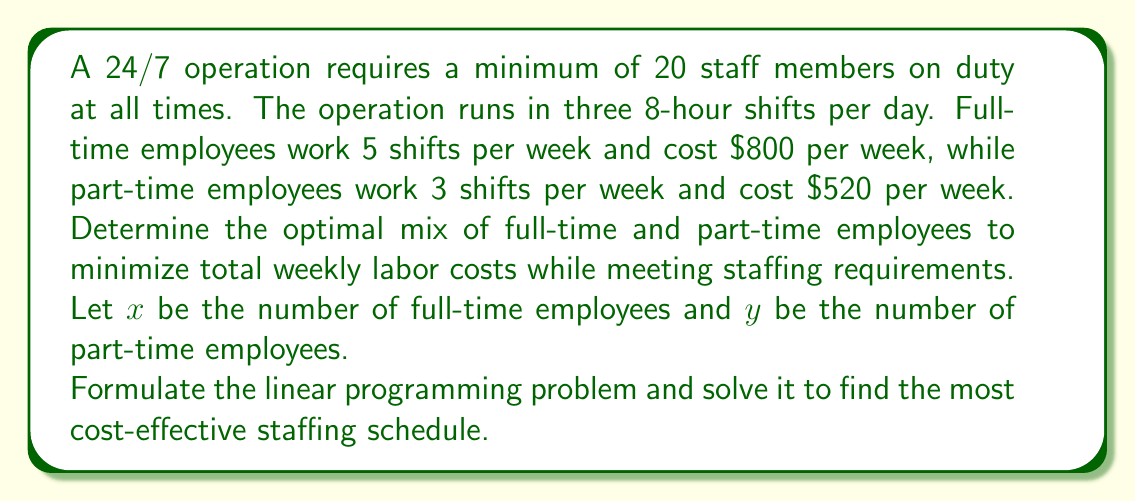Teach me how to tackle this problem. To solve this optimization problem, we need to formulate it as a linear programming problem and then solve it.

1. Objective function:
   Minimize total weekly cost: $C = 800x + 520y$

2. Constraints:
   a) Staffing requirement for each day:
      Full-time employees work 5 shifts per week, so on average 5/7 shifts per day.
      Part-time employees work 3 shifts per week, so on average 3/7 shifts per day.
      For each day: $\frac{5}{7}x + \frac{3}{7}y \geq 60$ (20 staff × 3 shifts)

   b) Non-negativity constraints:
      $x \geq 0$ and $y \geq 0$

3. Simplify the constraint:
   Multiply both sides by 7: $5x + 3y \geq 420$

4. Solve graphically or using the simplex method:
   The feasible region is bounded by the lines:
   $5x + 3y = 420$
   $x = 0$
   $y = 0$

   The optimal solution will be at one of the corner points of this region.

5. Corner points:
   a) (84, 0): C = 800(84) + 520(0) = 67,200
   b) (0, 140): C = 800(0) + 520(140) = 72,800
   c) Intersection of $5x + 3y = 420$ and $y = 0$: (84, 0)
   d) Intersection of $5x + 3y = 420$ and $x = 0$: (0, 140)

6. The optimal solution is at (84, 0), which means 84 full-time employees and 0 part-time employees.

7. Verify the solution:
   84 full-time employees work 84 × 5 = 420 shifts per week, which satisfies the requirement of 60 shifts per day or 420 shifts per week.
Answer: The optimal staffing schedule is to hire 84 full-time employees and 0 part-time employees, resulting in a minimum weekly labor cost of $67,200. 